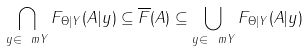Convert formula to latex. <formula><loc_0><loc_0><loc_500><loc_500>\bigcap _ { y \in \ m { Y } } F _ { \Theta | Y } ( A | y ) \subseteq \overline { F } ( A ) \subseteq \bigcup _ { y \in \ m { Y } } F _ { \Theta | Y } ( A | y )</formula> 